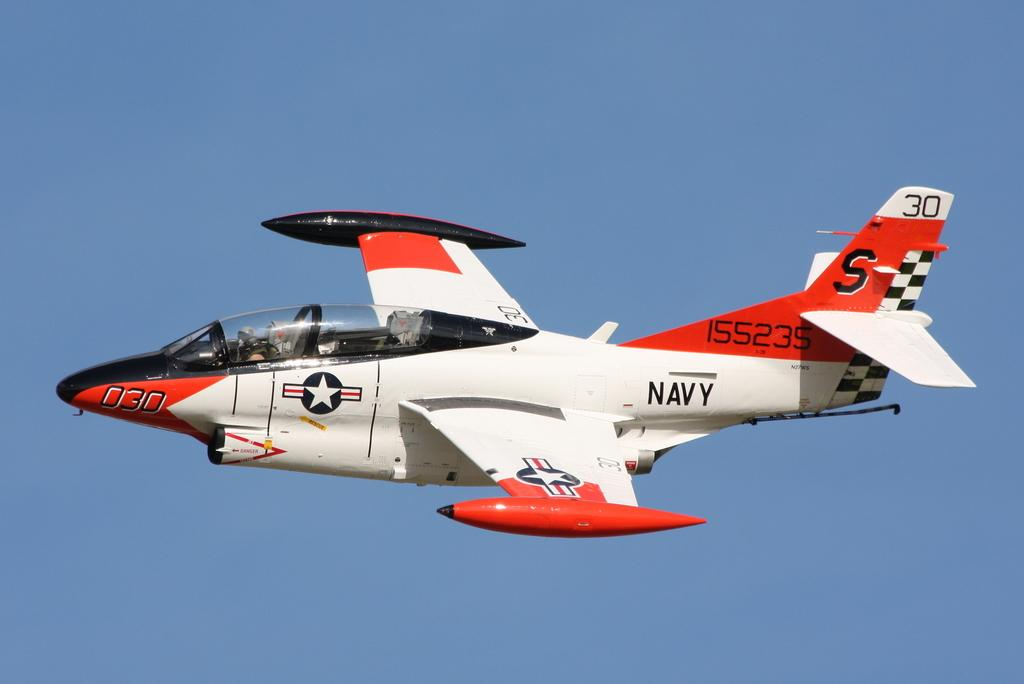Provide a one-sentence caption for the provided image. A red and white jet with the Navy logo written on the tail. 